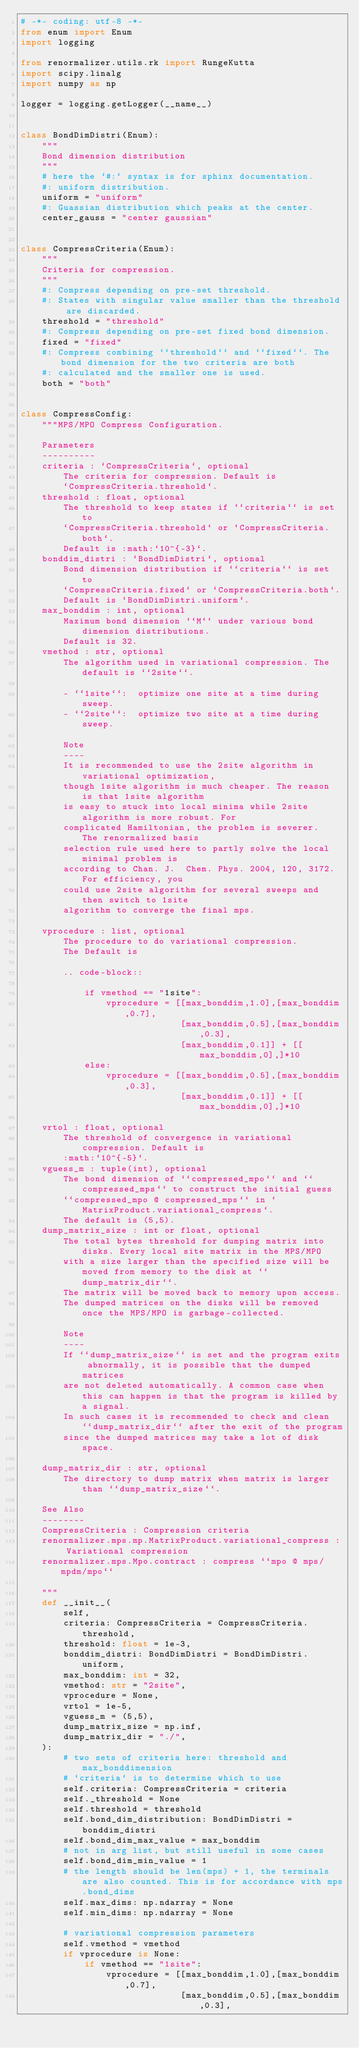<code> <loc_0><loc_0><loc_500><loc_500><_Python_># -*- coding: utf-8 -*-
from enum import Enum
import logging

from renormalizer.utils.rk import RungeKutta
import scipy.linalg
import numpy as np

logger = logging.getLogger(__name__)


class BondDimDistri(Enum):
    """
    Bond dimension distribution
    """
    # here the `#:` syntax is for sphinx documentation.
    #: uniform distribution.
    uniform = "uniform"
    #: Guassian distribution which peaks at the center.
    center_gauss = "center gaussian"


class CompressCriteria(Enum):
    """
    Criteria for compression.
    """
    #: Compress depending on pre-set threshold.
    #: States with singular value smaller than the threshold are discarded.
    threshold = "threshold"
    #: Compress depending on pre-set fixed bond dimension.
    fixed = "fixed"
    #: Compress combining ``threshold`` and ``fixed``. The bond dimension for the two criteria are both
    #: calculated and the smaller one is used.
    both = "both"


class CompressConfig:
    """MPS/MPO Compress Configuration.

    Parameters
    ----------
    criteria : `CompressCriteria`, optional
        The criteria for compression. Default is
        `CompressCriteria.threshold`.
    threshold : float, optional 
        The threshold to keep states if ``criteria`` is set to
        `CompressCriteria.threshold` or `CompressCriteria.both`.
        Default is :math:`10^{-3}`.
    bonddim_distri : `BondDimDistri`, optional
        Bond dimension distribution if ``criteria`` is set to
        `CompressCriteria.fixed` or `CompressCriteria.both`.
        Default is `BondDimDistri.uniform`.
    max_bonddim : int, optional
        Maximum bond dimension ``M`` under various bond dimension distributions.
        Default is 32.
    vmethod : str, optional
        The algorithm used in variational compression. The default is ``2site``.

        - ``1site``:  optimize one site at a time during sweep.
        - ``2site``:  optimize two site at a time during sweep.

        Note
        ----
        It is recommended to use the 2site algorithm in variational optimization,
        though 1site algorithm is much cheaper. The reason is that 1site algorithm
        is easy to stuck into local minima while 2site algorithm is more robust. For
        complicated Hamiltonian, the problem is severer.  The renormalized basis
        selection rule used here to partly solve the local minimal problem is
        according to Chan. J.  Chem. Phys. 2004, 120, 3172. For efficiency, you
        could use 2site algorithm for several sweeps and then switch to 1site
        algorithm to converge the final mps.

    vprocedure : list, optional
        The procedure to do variational compression.
        The Default is
        
        .. code-block::

            if vmethod == "1site":
                vprocedure = [[max_bonddim,1.0],[max_bonddim,0.7],
                              [max_bonddim,0.5],[max_bonddim,0.3],
                              [max_bonddim,0.1]] + [[max_bonddim,0],]*10
            else:
                vprocedure = [[max_bonddim,0.5],[max_bonddim,0.3],
                              [max_bonddim,0.1]] + [[max_bonddim,0],]*10
    
    vrtol : float, optional
        The threshold of convergence in variational compression. Default is
        :math:`10^{-5}`.
    vguess_m : tuple(int), optional
        The bond dimension of ``compressed_mpo`` and ``compressed_mps`` to construct the initial guess 
        ``compressed_mpo @ compressed_mps`` in `MatrixProduct.variational_compress`.
        The default is (5,5).
    dump_matrix_size : int or float, optional
        The total bytes threshold for dumping matrix into disks. Every local site matrix in the MPS/MPO
        with a size larger than the specified size will be moved from memory to the disk at ``dump_matrix_dir``.
        The matrix will be moved back to memory upon access.
        The dumped matrices on the disks will be removed once the MPS/MPO is garbage-collected.

        Note
        ----
        If ``dump_matrix_size`` is set and the program exits abnormally, it is possible that the dumped matrices
        are not deleted automatically. A common case when this can happen is that the program is killed by a signal.
        In such cases it is recommended to check and clean ``dump_matrix_dir`` after the exit of the program
        since the dumped matrices may take a lot of disk space.

    dump_matrix_dir : str, optional
        The directory to dump matrix when matrix is larger than ``dump_matrix_size``.

    See Also
    --------
    CompressCriteria : Compression criteria
    renormalizer.mps.mp.MatrixProduct.variational_compress : Variational compression
    renormalizer.mps.Mpo.contract : compress ``mpo @ mps/mpdm/mpo``
    
    """
    def __init__(
        self,
        criteria: CompressCriteria = CompressCriteria.threshold,
        threshold: float = 1e-3,
        bonddim_distri: BondDimDistri = BondDimDistri.uniform,
        max_bonddim: int = 32,
        vmethod: str = "2site",
        vprocedure = None,
        vrtol = 1e-5,
        vguess_m = (5,5),
        dump_matrix_size = np.inf,
        dump_matrix_dir = "./",
    ):
        # two sets of criteria here: threshold and max_bonddimension
        # `criteria` is to determine which to use
        self.criteria: CompressCriteria = criteria
        self._threshold = None
        self.threshold = threshold
        self.bond_dim_distribution: BondDimDistri = bonddim_distri
        self.bond_dim_max_value = max_bonddim
        # not in arg list, but still useful in some cases
        self.bond_dim_min_value = 1
        # the length should be len(mps) + 1, the terminals are also counted. This is for accordance with mps.bond_dims
        self.max_dims: np.ndarray = None
        self.min_dims: np.ndarray = None
        
        # variational compression parameters
        self.vmethod = vmethod
        if vprocedure is None:
            if vmethod == "1site":
                vprocedure = [[max_bonddim,1.0],[max_bonddim,0.7],
                              [max_bonddim,0.5],[max_bonddim,0.3],</code> 